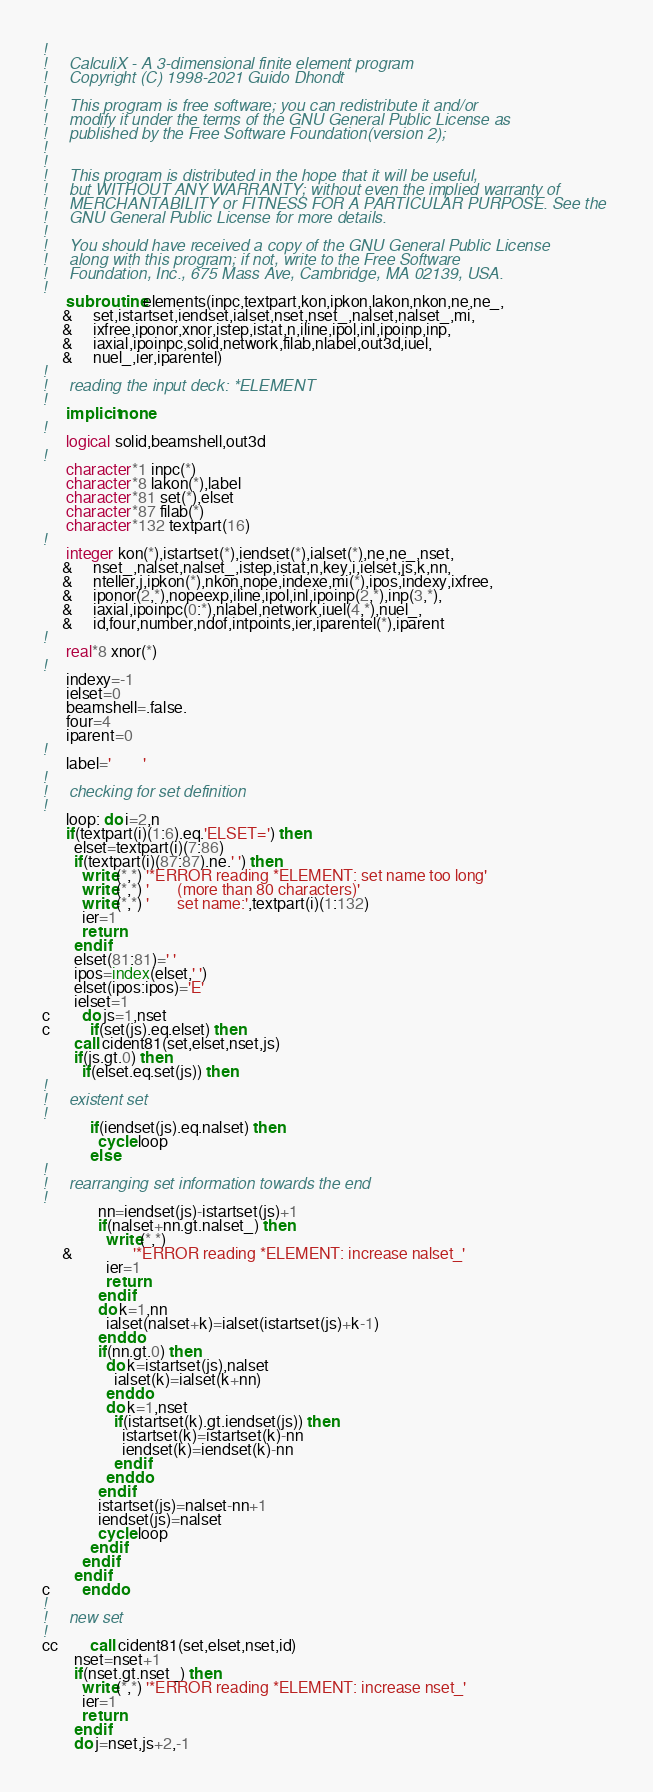<code> <loc_0><loc_0><loc_500><loc_500><_FORTRAN_>!     
!     CalculiX - A 3-dimensional finite element program
!     Copyright (C) 1998-2021 Guido Dhondt
!     
!     This program is free software; you can redistribute it and/or
!     modify it under the terms of the GNU General Public License as
!     published by the Free Software Foundation(version 2);
!     
!     
!     This program is distributed in the hope that it will be useful,
!     but WITHOUT ANY WARRANTY; without even the implied warranty of 
!     MERCHANTABILITY or FITNESS FOR A PARTICULAR PURPOSE. See the 
!     GNU General Public License for more details.
!     
!     You should have received a copy of the GNU General Public License
!     along with this program; if not, write to the Free Software
!     Foundation, Inc., 675 Mass Ave, Cambridge, MA 02139, USA.
!     
      subroutine elements(inpc,textpart,kon,ipkon,lakon,nkon,ne,ne_,
     &     set,istartset,iendset,ialset,nset,nset_,nalset,nalset_,mi,
     &     ixfree,iponor,xnor,istep,istat,n,iline,ipol,inl,ipoinp,inp,
     &     iaxial,ipoinpc,solid,network,filab,nlabel,out3d,iuel,
     &     nuel_,ier,iparentel)
!     
!     reading the input deck: *ELEMENT
!     
      implicit none
!     
      logical solid,beamshell,out3d
!     
      character*1 inpc(*)
      character*8 lakon(*),label
      character*81 set(*),elset
      character*87 filab(*)
      character*132 textpart(16)
!     
      integer kon(*),istartset(*),iendset(*),ialset(*),ne,ne_,nset,
     &     nset_,nalset,nalset_,istep,istat,n,key,i,ielset,js,k,nn,
     &     nteller,j,ipkon(*),nkon,nope,indexe,mi(*),ipos,indexy,ixfree,
     &     iponor(2,*),nopeexp,iline,ipol,inl,ipoinp(2,*),inp(3,*),
     &     iaxial,ipoinpc(0:*),nlabel,network,iuel(4,*),nuel_,
     &     id,four,number,ndof,intpoints,ier,iparentel(*),iparent
!     
      real*8 xnor(*)
!     
      indexy=-1
      ielset=0
      beamshell=.false.
      four=4
      iparent=0
!     
      label='        '
!     
!     checking for set definition
!     
      loop: do i=2,n
      if(textpart(i)(1:6).eq.'ELSET=') then
        elset=textpart(i)(7:86)
        if(textpart(i)(87:87).ne.' ') then
          write(*,*) '*ERROR reading *ELEMENT: set name too long'
          write(*,*) '       (more than 80 characters)'
          write(*,*) '       set name:',textpart(i)(1:132)
          ier=1
          return
        endif
        elset(81:81)=' '
        ipos=index(elset,' ')
        elset(ipos:ipos)='E'
        ielset=1
c        do js=1,nset
c          if(set(js).eq.elset) then
        call cident81(set,elset,nset,js)
        if(js.gt.0) then
          if(elset.eq.set(js)) then
!     
!     existent set
!     
            if(iendset(js).eq.nalset) then
              cycle loop
            else
!     
!     rearranging set information towards the end
!     
              nn=iendset(js)-istartset(js)+1
              if(nalset+nn.gt.nalset_) then
                write(*,*)
     &               '*ERROR reading *ELEMENT: increase nalset_'
                ier=1
                return
              endif
              do k=1,nn
                ialset(nalset+k)=ialset(istartset(js)+k-1)
              enddo
              if(nn.gt.0) then
                do k=istartset(js),nalset
                  ialset(k)=ialset(k+nn)
                enddo
                do k=1,nset
                  if(istartset(k).gt.iendset(js)) then
                    istartset(k)=istartset(k)-nn
                    iendset(k)=iendset(k)-nn
                  endif
                enddo
              endif
              istartset(js)=nalset-nn+1
              iendset(js)=nalset
              cycle loop
            endif
          endif
        endif
c        enddo
!     
!     new set
!     
cc        call cident81(set,elset,nset,id)
        nset=nset+1
        if(nset.gt.nset_) then
          write(*,*) '*ERROR reading *ELEMENT: increase nset_'
          ier=1
          return
        endif
        do j=nset,js+2,-1</code> 